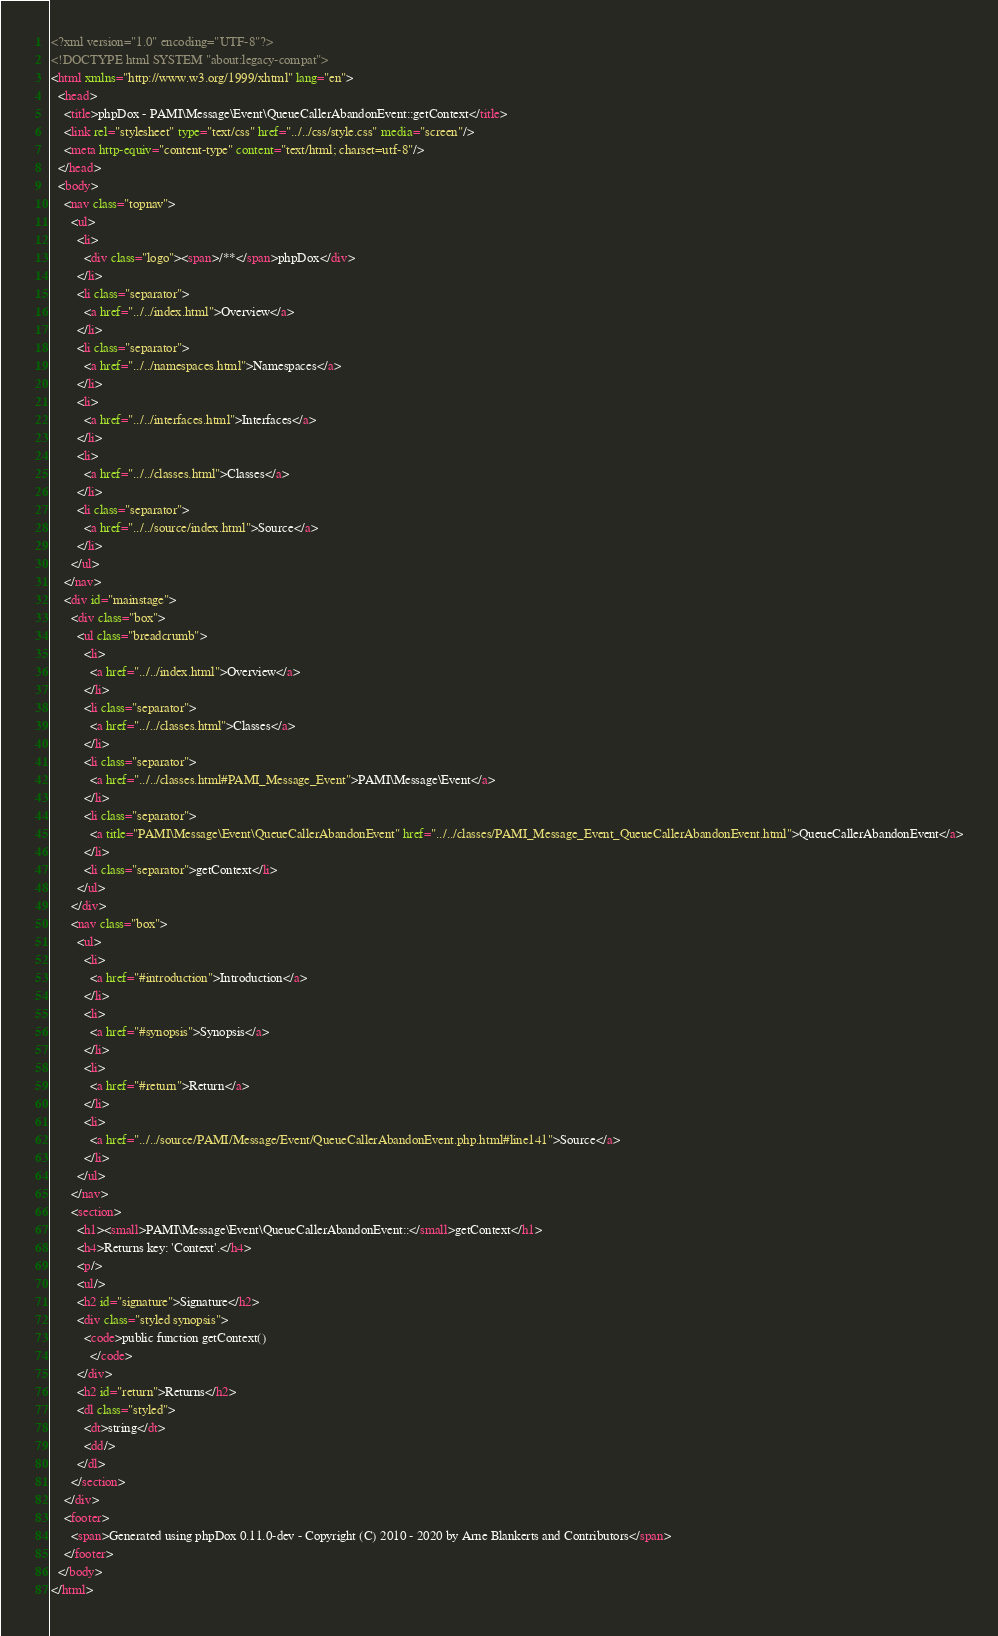Convert code to text. <code><loc_0><loc_0><loc_500><loc_500><_HTML_><?xml version="1.0" encoding="UTF-8"?>
<!DOCTYPE html SYSTEM "about:legacy-compat">
<html xmlns="http://www.w3.org/1999/xhtml" lang="en">
  <head>
    <title>phpDox - PAMI\Message\Event\QueueCallerAbandonEvent::getContext</title>
    <link rel="stylesheet" type="text/css" href="../../css/style.css" media="screen"/>
    <meta http-equiv="content-type" content="text/html; charset=utf-8"/>
  </head>
  <body>
    <nav class="topnav">
      <ul>
        <li>
          <div class="logo"><span>/**</span>phpDox</div>
        </li>
        <li class="separator">
          <a href="../../index.html">Overview</a>
        </li>
        <li class="separator">
          <a href="../../namespaces.html">Namespaces</a>
        </li>
        <li>
          <a href="../../interfaces.html">Interfaces</a>
        </li>
        <li>
          <a href="../../classes.html">Classes</a>
        </li>
        <li class="separator">
          <a href="../../source/index.html">Source</a>
        </li>
      </ul>
    </nav>
    <div id="mainstage">
      <div class="box">
        <ul class="breadcrumb">
          <li>
            <a href="../../index.html">Overview</a>
          </li>
          <li class="separator">
            <a href="../../classes.html">Classes</a>
          </li>
          <li class="separator">
            <a href="../../classes.html#PAMI_Message_Event">PAMI\Message\Event</a>
          </li>
          <li class="separator">
            <a title="PAMI\Message\Event\QueueCallerAbandonEvent" href="../../classes/PAMI_Message_Event_QueueCallerAbandonEvent.html">QueueCallerAbandonEvent</a>
          </li>
          <li class="separator">getContext</li>
        </ul>
      </div>
      <nav class="box">
        <ul>
          <li>
            <a href="#introduction">Introduction</a>
          </li>
          <li>
            <a href="#synopsis">Synopsis</a>
          </li>
          <li>
            <a href="#return">Return</a>
          </li>
          <li>
            <a href="../../source/PAMI/Message/Event/QueueCallerAbandonEvent.php.html#line141">Source</a>
          </li>
        </ul>
      </nav>
      <section>
        <h1><small>PAMI\Message\Event\QueueCallerAbandonEvent::</small>getContext</h1>
        <h4>Returns key: 'Context'.</h4>
        <p/>
        <ul/>
        <h2 id="signature">Signature</h2>
        <div class="styled synopsis">
          <code>public function getContext()
            </code>
        </div>
        <h2 id="return">Returns</h2>
        <dl class="styled">
          <dt>string</dt>
          <dd/>
        </dl>
      </section>
    </div>
    <footer>
      <span>Generated using phpDox 0.11.0-dev - Copyright (C) 2010 - 2020 by Arne Blankerts and Contributors</span>
    </footer>
  </body>
</html>
</code> 